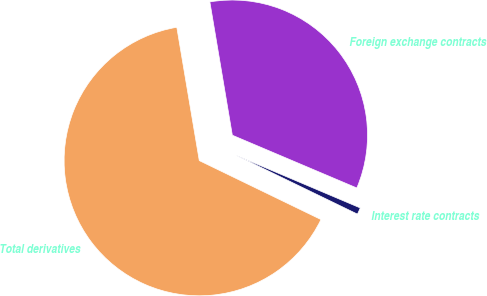Convert chart. <chart><loc_0><loc_0><loc_500><loc_500><pie_chart><fcel>Interest rate contracts<fcel>Foreign exchange contracts<fcel>Total derivatives<nl><fcel>0.8%<fcel>34.04%<fcel>65.16%<nl></chart> 